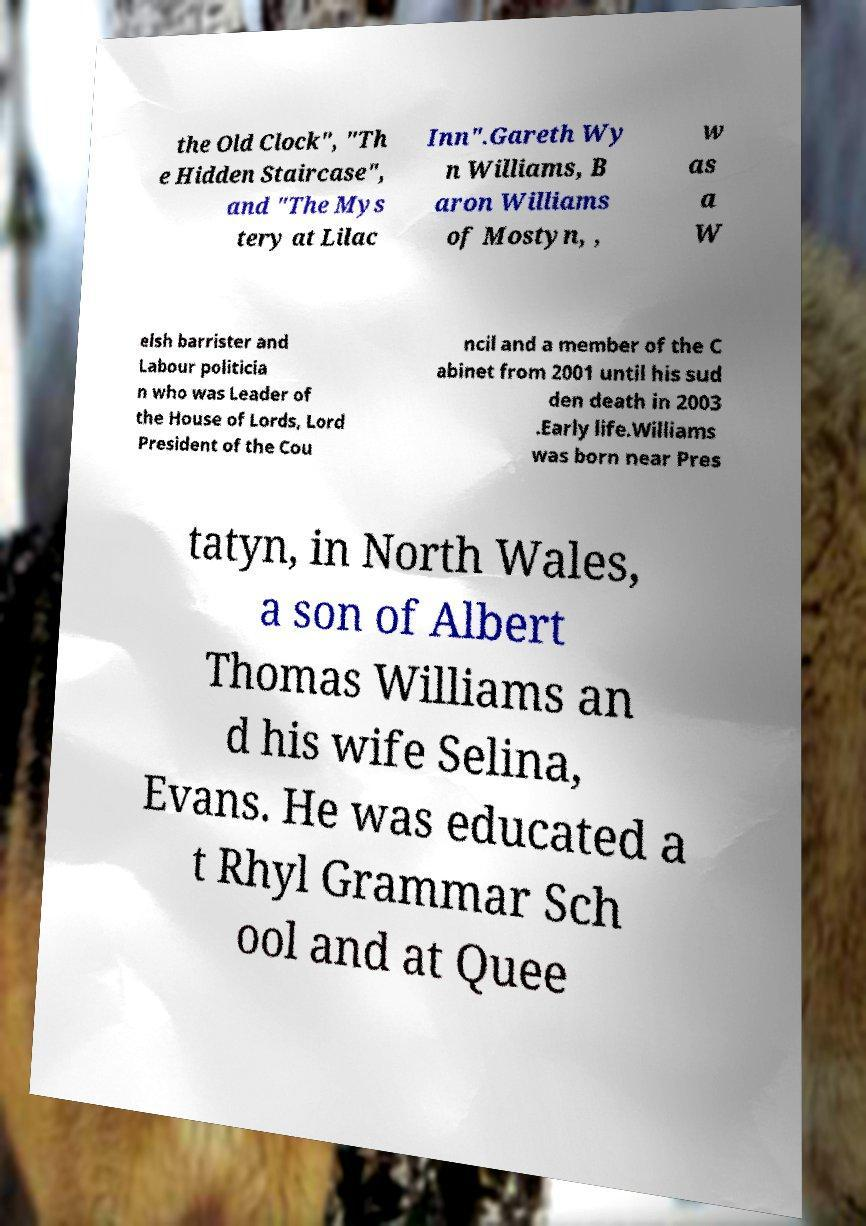Please read and relay the text visible in this image. What does it say? the Old Clock", "Th e Hidden Staircase", and "The Mys tery at Lilac Inn".Gareth Wy n Williams, B aron Williams of Mostyn, , w as a W elsh barrister and Labour politicia n who was Leader of the House of Lords, Lord President of the Cou ncil and a member of the C abinet from 2001 until his sud den death in 2003 .Early life.Williams was born near Pres tatyn, in North Wales, a son of Albert Thomas Williams an d his wife Selina, Evans. He was educated a t Rhyl Grammar Sch ool and at Quee 